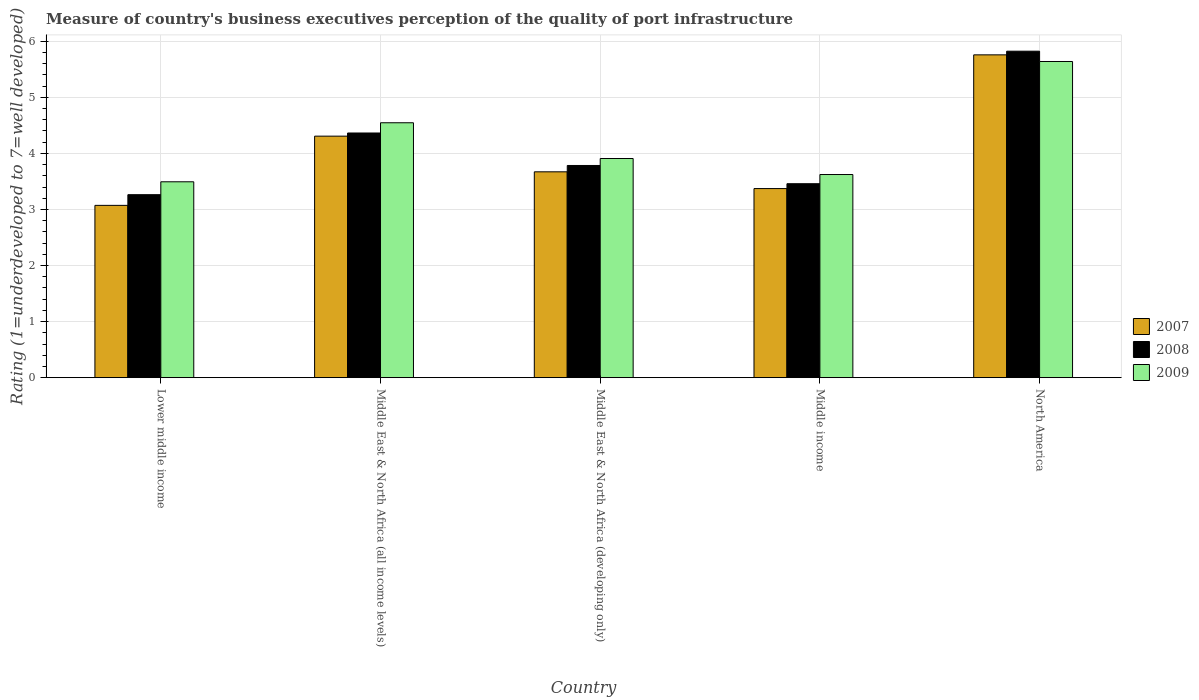How many different coloured bars are there?
Make the answer very short. 3. Are the number of bars per tick equal to the number of legend labels?
Ensure brevity in your answer.  Yes. Are the number of bars on each tick of the X-axis equal?
Make the answer very short. Yes. How many bars are there on the 5th tick from the left?
Provide a short and direct response. 3. How many bars are there on the 2nd tick from the right?
Provide a short and direct response. 3. What is the label of the 5th group of bars from the left?
Your response must be concise. North America. What is the ratings of the quality of port infrastructure in 2008 in Lower middle income?
Ensure brevity in your answer.  3.26. Across all countries, what is the maximum ratings of the quality of port infrastructure in 2008?
Provide a short and direct response. 5.82. Across all countries, what is the minimum ratings of the quality of port infrastructure in 2009?
Keep it short and to the point. 3.49. In which country was the ratings of the quality of port infrastructure in 2007 maximum?
Give a very brief answer. North America. In which country was the ratings of the quality of port infrastructure in 2008 minimum?
Keep it short and to the point. Lower middle income. What is the total ratings of the quality of port infrastructure in 2008 in the graph?
Make the answer very short. 20.7. What is the difference between the ratings of the quality of port infrastructure in 2007 in Middle East & North Africa (all income levels) and that in Middle income?
Ensure brevity in your answer.  0.94. What is the difference between the ratings of the quality of port infrastructure in 2007 in North America and the ratings of the quality of port infrastructure in 2008 in Middle income?
Your answer should be compact. 2.3. What is the average ratings of the quality of port infrastructure in 2009 per country?
Make the answer very short. 4.24. What is the difference between the ratings of the quality of port infrastructure of/in 2008 and ratings of the quality of port infrastructure of/in 2007 in Middle income?
Give a very brief answer. 0.09. In how many countries, is the ratings of the quality of port infrastructure in 2009 greater than 2.6?
Give a very brief answer. 5. What is the ratio of the ratings of the quality of port infrastructure in 2009 in Middle East & North Africa (all income levels) to that in North America?
Give a very brief answer. 0.81. What is the difference between the highest and the second highest ratings of the quality of port infrastructure in 2008?
Offer a very short reply. -0.58. What is the difference between the highest and the lowest ratings of the quality of port infrastructure in 2007?
Provide a short and direct response. 2.68. In how many countries, is the ratings of the quality of port infrastructure in 2007 greater than the average ratings of the quality of port infrastructure in 2007 taken over all countries?
Make the answer very short. 2. What does the 3rd bar from the left in Lower middle income represents?
Offer a very short reply. 2009. What does the 2nd bar from the right in Middle East & North Africa (developing only) represents?
Make the answer very short. 2008. Is it the case that in every country, the sum of the ratings of the quality of port infrastructure in 2007 and ratings of the quality of port infrastructure in 2008 is greater than the ratings of the quality of port infrastructure in 2009?
Your answer should be compact. Yes. How many countries are there in the graph?
Give a very brief answer. 5. What is the difference between two consecutive major ticks on the Y-axis?
Give a very brief answer. 1. Does the graph contain grids?
Provide a succinct answer. Yes. Where does the legend appear in the graph?
Your response must be concise. Center right. How are the legend labels stacked?
Provide a short and direct response. Vertical. What is the title of the graph?
Your answer should be compact. Measure of country's business executives perception of the quality of port infrastructure. Does "1970" appear as one of the legend labels in the graph?
Give a very brief answer. No. What is the label or title of the X-axis?
Provide a succinct answer. Country. What is the label or title of the Y-axis?
Offer a terse response. Rating (1=underdeveloped to 7=well developed). What is the Rating (1=underdeveloped to 7=well developed) of 2007 in Lower middle income?
Provide a short and direct response. 3.07. What is the Rating (1=underdeveloped to 7=well developed) in 2008 in Lower middle income?
Provide a succinct answer. 3.26. What is the Rating (1=underdeveloped to 7=well developed) in 2009 in Lower middle income?
Give a very brief answer. 3.49. What is the Rating (1=underdeveloped to 7=well developed) of 2007 in Middle East & North Africa (all income levels)?
Your answer should be compact. 4.31. What is the Rating (1=underdeveloped to 7=well developed) in 2008 in Middle East & North Africa (all income levels)?
Your answer should be very brief. 4.36. What is the Rating (1=underdeveloped to 7=well developed) in 2009 in Middle East & North Africa (all income levels)?
Keep it short and to the point. 4.55. What is the Rating (1=underdeveloped to 7=well developed) in 2007 in Middle East & North Africa (developing only)?
Offer a very short reply. 3.67. What is the Rating (1=underdeveloped to 7=well developed) in 2008 in Middle East & North Africa (developing only)?
Provide a succinct answer. 3.78. What is the Rating (1=underdeveloped to 7=well developed) in 2009 in Middle East & North Africa (developing only)?
Provide a succinct answer. 3.91. What is the Rating (1=underdeveloped to 7=well developed) of 2007 in Middle income?
Provide a short and direct response. 3.37. What is the Rating (1=underdeveloped to 7=well developed) of 2008 in Middle income?
Provide a short and direct response. 3.46. What is the Rating (1=underdeveloped to 7=well developed) of 2009 in Middle income?
Keep it short and to the point. 3.62. What is the Rating (1=underdeveloped to 7=well developed) in 2007 in North America?
Give a very brief answer. 5.76. What is the Rating (1=underdeveloped to 7=well developed) in 2008 in North America?
Ensure brevity in your answer.  5.82. What is the Rating (1=underdeveloped to 7=well developed) of 2009 in North America?
Your answer should be compact. 5.64. Across all countries, what is the maximum Rating (1=underdeveloped to 7=well developed) in 2007?
Your response must be concise. 5.76. Across all countries, what is the maximum Rating (1=underdeveloped to 7=well developed) of 2008?
Your response must be concise. 5.82. Across all countries, what is the maximum Rating (1=underdeveloped to 7=well developed) in 2009?
Offer a terse response. 5.64. Across all countries, what is the minimum Rating (1=underdeveloped to 7=well developed) of 2007?
Ensure brevity in your answer.  3.07. Across all countries, what is the minimum Rating (1=underdeveloped to 7=well developed) in 2008?
Offer a terse response. 3.26. Across all countries, what is the minimum Rating (1=underdeveloped to 7=well developed) of 2009?
Ensure brevity in your answer.  3.49. What is the total Rating (1=underdeveloped to 7=well developed) in 2007 in the graph?
Your response must be concise. 20.18. What is the total Rating (1=underdeveloped to 7=well developed) of 2008 in the graph?
Offer a very short reply. 20.7. What is the total Rating (1=underdeveloped to 7=well developed) of 2009 in the graph?
Your answer should be very brief. 21.21. What is the difference between the Rating (1=underdeveloped to 7=well developed) in 2007 in Lower middle income and that in Middle East & North Africa (all income levels)?
Give a very brief answer. -1.23. What is the difference between the Rating (1=underdeveloped to 7=well developed) of 2008 in Lower middle income and that in Middle East & North Africa (all income levels)?
Your response must be concise. -1.1. What is the difference between the Rating (1=underdeveloped to 7=well developed) of 2009 in Lower middle income and that in Middle East & North Africa (all income levels)?
Offer a very short reply. -1.05. What is the difference between the Rating (1=underdeveloped to 7=well developed) of 2007 in Lower middle income and that in Middle East & North Africa (developing only)?
Make the answer very short. -0.6. What is the difference between the Rating (1=underdeveloped to 7=well developed) of 2008 in Lower middle income and that in Middle East & North Africa (developing only)?
Give a very brief answer. -0.52. What is the difference between the Rating (1=underdeveloped to 7=well developed) of 2009 in Lower middle income and that in Middle East & North Africa (developing only)?
Keep it short and to the point. -0.42. What is the difference between the Rating (1=underdeveloped to 7=well developed) of 2007 in Lower middle income and that in Middle income?
Your answer should be very brief. -0.3. What is the difference between the Rating (1=underdeveloped to 7=well developed) in 2008 in Lower middle income and that in Middle income?
Offer a terse response. -0.2. What is the difference between the Rating (1=underdeveloped to 7=well developed) in 2009 in Lower middle income and that in Middle income?
Make the answer very short. -0.13. What is the difference between the Rating (1=underdeveloped to 7=well developed) of 2007 in Lower middle income and that in North America?
Make the answer very short. -2.68. What is the difference between the Rating (1=underdeveloped to 7=well developed) in 2008 in Lower middle income and that in North America?
Offer a terse response. -2.56. What is the difference between the Rating (1=underdeveloped to 7=well developed) of 2009 in Lower middle income and that in North America?
Ensure brevity in your answer.  -2.15. What is the difference between the Rating (1=underdeveloped to 7=well developed) of 2007 in Middle East & North Africa (all income levels) and that in Middle East & North Africa (developing only)?
Provide a succinct answer. 0.64. What is the difference between the Rating (1=underdeveloped to 7=well developed) in 2008 in Middle East & North Africa (all income levels) and that in Middle East & North Africa (developing only)?
Your answer should be very brief. 0.58. What is the difference between the Rating (1=underdeveloped to 7=well developed) in 2009 in Middle East & North Africa (all income levels) and that in Middle East & North Africa (developing only)?
Your response must be concise. 0.64. What is the difference between the Rating (1=underdeveloped to 7=well developed) in 2007 in Middle East & North Africa (all income levels) and that in Middle income?
Offer a terse response. 0.94. What is the difference between the Rating (1=underdeveloped to 7=well developed) in 2008 in Middle East & North Africa (all income levels) and that in Middle income?
Provide a short and direct response. 0.9. What is the difference between the Rating (1=underdeveloped to 7=well developed) of 2009 in Middle East & North Africa (all income levels) and that in Middle income?
Provide a succinct answer. 0.92. What is the difference between the Rating (1=underdeveloped to 7=well developed) of 2007 in Middle East & North Africa (all income levels) and that in North America?
Your answer should be very brief. -1.45. What is the difference between the Rating (1=underdeveloped to 7=well developed) of 2008 in Middle East & North Africa (all income levels) and that in North America?
Your response must be concise. -1.46. What is the difference between the Rating (1=underdeveloped to 7=well developed) in 2009 in Middle East & North Africa (all income levels) and that in North America?
Make the answer very short. -1.09. What is the difference between the Rating (1=underdeveloped to 7=well developed) in 2007 in Middle East & North Africa (developing only) and that in Middle income?
Your answer should be compact. 0.3. What is the difference between the Rating (1=underdeveloped to 7=well developed) of 2008 in Middle East & North Africa (developing only) and that in Middle income?
Keep it short and to the point. 0.33. What is the difference between the Rating (1=underdeveloped to 7=well developed) of 2009 in Middle East & North Africa (developing only) and that in Middle income?
Offer a terse response. 0.29. What is the difference between the Rating (1=underdeveloped to 7=well developed) in 2007 in Middle East & North Africa (developing only) and that in North America?
Your response must be concise. -2.09. What is the difference between the Rating (1=underdeveloped to 7=well developed) of 2008 in Middle East & North Africa (developing only) and that in North America?
Give a very brief answer. -2.04. What is the difference between the Rating (1=underdeveloped to 7=well developed) of 2009 in Middle East & North Africa (developing only) and that in North America?
Your answer should be compact. -1.73. What is the difference between the Rating (1=underdeveloped to 7=well developed) in 2007 in Middle income and that in North America?
Your answer should be very brief. -2.39. What is the difference between the Rating (1=underdeveloped to 7=well developed) in 2008 in Middle income and that in North America?
Offer a terse response. -2.36. What is the difference between the Rating (1=underdeveloped to 7=well developed) in 2009 in Middle income and that in North America?
Provide a succinct answer. -2.02. What is the difference between the Rating (1=underdeveloped to 7=well developed) of 2007 in Lower middle income and the Rating (1=underdeveloped to 7=well developed) of 2008 in Middle East & North Africa (all income levels)?
Provide a short and direct response. -1.29. What is the difference between the Rating (1=underdeveloped to 7=well developed) of 2007 in Lower middle income and the Rating (1=underdeveloped to 7=well developed) of 2009 in Middle East & North Africa (all income levels)?
Your answer should be compact. -1.47. What is the difference between the Rating (1=underdeveloped to 7=well developed) of 2008 in Lower middle income and the Rating (1=underdeveloped to 7=well developed) of 2009 in Middle East & North Africa (all income levels)?
Your answer should be very brief. -1.28. What is the difference between the Rating (1=underdeveloped to 7=well developed) in 2007 in Lower middle income and the Rating (1=underdeveloped to 7=well developed) in 2008 in Middle East & North Africa (developing only)?
Ensure brevity in your answer.  -0.71. What is the difference between the Rating (1=underdeveloped to 7=well developed) in 2007 in Lower middle income and the Rating (1=underdeveloped to 7=well developed) in 2009 in Middle East & North Africa (developing only)?
Your answer should be compact. -0.84. What is the difference between the Rating (1=underdeveloped to 7=well developed) of 2008 in Lower middle income and the Rating (1=underdeveloped to 7=well developed) of 2009 in Middle East & North Africa (developing only)?
Your response must be concise. -0.65. What is the difference between the Rating (1=underdeveloped to 7=well developed) of 2007 in Lower middle income and the Rating (1=underdeveloped to 7=well developed) of 2008 in Middle income?
Offer a very short reply. -0.39. What is the difference between the Rating (1=underdeveloped to 7=well developed) of 2007 in Lower middle income and the Rating (1=underdeveloped to 7=well developed) of 2009 in Middle income?
Provide a short and direct response. -0.55. What is the difference between the Rating (1=underdeveloped to 7=well developed) of 2008 in Lower middle income and the Rating (1=underdeveloped to 7=well developed) of 2009 in Middle income?
Give a very brief answer. -0.36. What is the difference between the Rating (1=underdeveloped to 7=well developed) in 2007 in Lower middle income and the Rating (1=underdeveloped to 7=well developed) in 2008 in North America?
Offer a very short reply. -2.75. What is the difference between the Rating (1=underdeveloped to 7=well developed) in 2007 in Lower middle income and the Rating (1=underdeveloped to 7=well developed) in 2009 in North America?
Your response must be concise. -2.57. What is the difference between the Rating (1=underdeveloped to 7=well developed) of 2008 in Lower middle income and the Rating (1=underdeveloped to 7=well developed) of 2009 in North America?
Offer a terse response. -2.38. What is the difference between the Rating (1=underdeveloped to 7=well developed) of 2007 in Middle East & North Africa (all income levels) and the Rating (1=underdeveloped to 7=well developed) of 2008 in Middle East & North Africa (developing only)?
Offer a very short reply. 0.52. What is the difference between the Rating (1=underdeveloped to 7=well developed) in 2007 in Middle East & North Africa (all income levels) and the Rating (1=underdeveloped to 7=well developed) in 2009 in Middle East & North Africa (developing only)?
Give a very brief answer. 0.4. What is the difference between the Rating (1=underdeveloped to 7=well developed) in 2008 in Middle East & North Africa (all income levels) and the Rating (1=underdeveloped to 7=well developed) in 2009 in Middle East & North Africa (developing only)?
Make the answer very short. 0.46. What is the difference between the Rating (1=underdeveloped to 7=well developed) of 2007 in Middle East & North Africa (all income levels) and the Rating (1=underdeveloped to 7=well developed) of 2008 in Middle income?
Your answer should be compact. 0.85. What is the difference between the Rating (1=underdeveloped to 7=well developed) of 2007 in Middle East & North Africa (all income levels) and the Rating (1=underdeveloped to 7=well developed) of 2009 in Middle income?
Provide a succinct answer. 0.68. What is the difference between the Rating (1=underdeveloped to 7=well developed) of 2008 in Middle East & North Africa (all income levels) and the Rating (1=underdeveloped to 7=well developed) of 2009 in Middle income?
Offer a very short reply. 0.74. What is the difference between the Rating (1=underdeveloped to 7=well developed) of 2007 in Middle East & North Africa (all income levels) and the Rating (1=underdeveloped to 7=well developed) of 2008 in North America?
Offer a very short reply. -1.52. What is the difference between the Rating (1=underdeveloped to 7=well developed) of 2007 in Middle East & North Africa (all income levels) and the Rating (1=underdeveloped to 7=well developed) of 2009 in North America?
Keep it short and to the point. -1.33. What is the difference between the Rating (1=underdeveloped to 7=well developed) in 2008 in Middle East & North Africa (all income levels) and the Rating (1=underdeveloped to 7=well developed) in 2009 in North America?
Provide a succinct answer. -1.28. What is the difference between the Rating (1=underdeveloped to 7=well developed) in 2007 in Middle East & North Africa (developing only) and the Rating (1=underdeveloped to 7=well developed) in 2008 in Middle income?
Make the answer very short. 0.21. What is the difference between the Rating (1=underdeveloped to 7=well developed) in 2007 in Middle East & North Africa (developing only) and the Rating (1=underdeveloped to 7=well developed) in 2009 in Middle income?
Give a very brief answer. 0.05. What is the difference between the Rating (1=underdeveloped to 7=well developed) in 2008 in Middle East & North Africa (developing only) and the Rating (1=underdeveloped to 7=well developed) in 2009 in Middle income?
Offer a very short reply. 0.16. What is the difference between the Rating (1=underdeveloped to 7=well developed) in 2007 in Middle East & North Africa (developing only) and the Rating (1=underdeveloped to 7=well developed) in 2008 in North America?
Your answer should be very brief. -2.15. What is the difference between the Rating (1=underdeveloped to 7=well developed) in 2007 in Middle East & North Africa (developing only) and the Rating (1=underdeveloped to 7=well developed) in 2009 in North America?
Ensure brevity in your answer.  -1.97. What is the difference between the Rating (1=underdeveloped to 7=well developed) in 2008 in Middle East & North Africa (developing only) and the Rating (1=underdeveloped to 7=well developed) in 2009 in North America?
Provide a short and direct response. -1.85. What is the difference between the Rating (1=underdeveloped to 7=well developed) of 2007 in Middle income and the Rating (1=underdeveloped to 7=well developed) of 2008 in North America?
Offer a very short reply. -2.45. What is the difference between the Rating (1=underdeveloped to 7=well developed) in 2007 in Middle income and the Rating (1=underdeveloped to 7=well developed) in 2009 in North America?
Ensure brevity in your answer.  -2.27. What is the difference between the Rating (1=underdeveloped to 7=well developed) of 2008 in Middle income and the Rating (1=underdeveloped to 7=well developed) of 2009 in North America?
Give a very brief answer. -2.18. What is the average Rating (1=underdeveloped to 7=well developed) of 2007 per country?
Offer a very short reply. 4.04. What is the average Rating (1=underdeveloped to 7=well developed) in 2008 per country?
Provide a succinct answer. 4.14. What is the average Rating (1=underdeveloped to 7=well developed) of 2009 per country?
Provide a short and direct response. 4.24. What is the difference between the Rating (1=underdeveloped to 7=well developed) in 2007 and Rating (1=underdeveloped to 7=well developed) in 2008 in Lower middle income?
Keep it short and to the point. -0.19. What is the difference between the Rating (1=underdeveloped to 7=well developed) of 2007 and Rating (1=underdeveloped to 7=well developed) of 2009 in Lower middle income?
Offer a terse response. -0.42. What is the difference between the Rating (1=underdeveloped to 7=well developed) of 2008 and Rating (1=underdeveloped to 7=well developed) of 2009 in Lower middle income?
Offer a very short reply. -0.23. What is the difference between the Rating (1=underdeveloped to 7=well developed) of 2007 and Rating (1=underdeveloped to 7=well developed) of 2008 in Middle East & North Africa (all income levels)?
Ensure brevity in your answer.  -0.06. What is the difference between the Rating (1=underdeveloped to 7=well developed) in 2007 and Rating (1=underdeveloped to 7=well developed) in 2009 in Middle East & North Africa (all income levels)?
Provide a succinct answer. -0.24. What is the difference between the Rating (1=underdeveloped to 7=well developed) in 2008 and Rating (1=underdeveloped to 7=well developed) in 2009 in Middle East & North Africa (all income levels)?
Offer a very short reply. -0.18. What is the difference between the Rating (1=underdeveloped to 7=well developed) of 2007 and Rating (1=underdeveloped to 7=well developed) of 2008 in Middle East & North Africa (developing only)?
Your answer should be very brief. -0.11. What is the difference between the Rating (1=underdeveloped to 7=well developed) of 2007 and Rating (1=underdeveloped to 7=well developed) of 2009 in Middle East & North Africa (developing only)?
Your response must be concise. -0.24. What is the difference between the Rating (1=underdeveloped to 7=well developed) in 2008 and Rating (1=underdeveloped to 7=well developed) in 2009 in Middle East & North Africa (developing only)?
Provide a succinct answer. -0.12. What is the difference between the Rating (1=underdeveloped to 7=well developed) in 2007 and Rating (1=underdeveloped to 7=well developed) in 2008 in Middle income?
Your response must be concise. -0.09. What is the difference between the Rating (1=underdeveloped to 7=well developed) in 2007 and Rating (1=underdeveloped to 7=well developed) in 2009 in Middle income?
Make the answer very short. -0.25. What is the difference between the Rating (1=underdeveloped to 7=well developed) of 2008 and Rating (1=underdeveloped to 7=well developed) of 2009 in Middle income?
Give a very brief answer. -0.16. What is the difference between the Rating (1=underdeveloped to 7=well developed) of 2007 and Rating (1=underdeveloped to 7=well developed) of 2008 in North America?
Provide a succinct answer. -0.07. What is the difference between the Rating (1=underdeveloped to 7=well developed) in 2007 and Rating (1=underdeveloped to 7=well developed) in 2009 in North America?
Keep it short and to the point. 0.12. What is the difference between the Rating (1=underdeveloped to 7=well developed) of 2008 and Rating (1=underdeveloped to 7=well developed) of 2009 in North America?
Your answer should be very brief. 0.18. What is the ratio of the Rating (1=underdeveloped to 7=well developed) in 2007 in Lower middle income to that in Middle East & North Africa (all income levels)?
Keep it short and to the point. 0.71. What is the ratio of the Rating (1=underdeveloped to 7=well developed) of 2008 in Lower middle income to that in Middle East & North Africa (all income levels)?
Your response must be concise. 0.75. What is the ratio of the Rating (1=underdeveloped to 7=well developed) of 2009 in Lower middle income to that in Middle East & North Africa (all income levels)?
Offer a very short reply. 0.77. What is the ratio of the Rating (1=underdeveloped to 7=well developed) of 2007 in Lower middle income to that in Middle East & North Africa (developing only)?
Provide a short and direct response. 0.84. What is the ratio of the Rating (1=underdeveloped to 7=well developed) in 2008 in Lower middle income to that in Middle East & North Africa (developing only)?
Your answer should be very brief. 0.86. What is the ratio of the Rating (1=underdeveloped to 7=well developed) in 2009 in Lower middle income to that in Middle East & North Africa (developing only)?
Your response must be concise. 0.89. What is the ratio of the Rating (1=underdeveloped to 7=well developed) in 2007 in Lower middle income to that in Middle income?
Your answer should be very brief. 0.91. What is the ratio of the Rating (1=underdeveloped to 7=well developed) of 2008 in Lower middle income to that in Middle income?
Make the answer very short. 0.94. What is the ratio of the Rating (1=underdeveloped to 7=well developed) of 2009 in Lower middle income to that in Middle income?
Provide a short and direct response. 0.96. What is the ratio of the Rating (1=underdeveloped to 7=well developed) in 2007 in Lower middle income to that in North America?
Ensure brevity in your answer.  0.53. What is the ratio of the Rating (1=underdeveloped to 7=well developed) of 2008 in Lower middle income to that in North America?
Keep it short and to the point. 0.56. What is the ratio of the Rating (1=underdeveloped to 7=well developed) of 2009 in Lower middle income to that in North America?
Your response must be concise. 0.62. What is the ratio of the Rating (1=underdeveloped to 7=well developed) of 2007 in Middle East & North Africa (all income levels) to that in Middle East & North Africa (developing only)?
Offer a terse response. 1.17. What is the ratio of the Rating (1=underdeveloped to 7=well developed) in 2008 in Middle East & North Africa (all income levels) to that in Middle East & North Africa (developing only)?
Offer a very short reply. 1.15. What is the ratio of the Rating (1=underdeveloped to 7=well developed) in 2009 in Middle East & North Africa (all income levels) to that in Middle East & North Africa (developing only)?
Your answer should be very brief. 1.16. What is the ratio of the Rating (1=underdeveloped to 7=well developed) of 2007 in Middle East & North Africa (all income levels) to that in Middle income?
Keep it short and to the point. 1.28. What is the ratio of the Rating (1=underdeveloped to 7=well developed) of 2008 in Middle East & North Africa (all income levels) to that in Middle income?
Give a very brief answer. 1.26. What is the ratio of the Rating (1=underdeveloped to 7=well developed) of 2009 in Middle East & North Africa (all income levels) to that in Middle income?
Your answer should be compact. 1.25. What is the ratio of the Rating (1=underdeveloped to 7=well developed) in 2007 in Middle East & North Africa (all income levels) to that in North America?
Offer a terse response. 0.75. What is the ratio of the Rating (1=underdeveloped to 7=well developed) of 2008 in Middle East & North Africa (all income levels) to that in North America?
Offer a terse response. 0.75. What is the ratio of the Rating (1=underdeveloped to 7=well developed) in 2009 in Middle East & North Africa (all income levels) to that in North America?
Your answer should be compact. 0.81. What is the ratio of the Rating (1=underdeveloped to 7=well developed) in 2007 in Middle East & North Africa (developing only) to that in Middle income?
Make the answer very short. 1.09. What is the ratio of the Rating (1=underdeveloped to 7=well developed) in 2008 in Middle East & North Africa (developing only) to that in Middle income?
Keep it short and to the point. 1.09. What is the ratio of the Rating (1=underdeveloped to 7=well developed) in 2009 in Middle East & North Africa (developing only) to that in Middle income?
Your answer should be very brief. 1.08. What is the ratio of the Rating (1=underdeveloped to 7=well developed) in 2007 in Middle East & North Africa (developing only) to that in North America?
Offer a very short reply. 0.64. What is the ratio of the Rating (1=underdeveloped to 7=well developed) in 2008 in Middle East & North Africa (developing only) to that in North America?
Ensure brevity in your answer.  0.65. What is the ratio of the Rating (1=underdeveloped to 7=well developed) in 2009 in Middle East & North Africa (developing only) to that in North America?
Make the answer very short. 0.69. What is the ratio of the Rating (1=underdeveloped to 7=well developed) of 2007 in Middle income to that in North America?
Give a very brief answer. 0.59. What is the ratio of the Rating (1=underdeveloped to 7=well developed) in 2008 in Middle income to that in North America?
Your response must be concise. 0.59. What is the ratio of the Rating (1=underdeveloped to 7=well developed) in 2009 in Middle income to that in North America?
Your response must be concise. 0.64. What is the difference between the highest and the second highest Rating (1=underdeveloped to 7=well developed) in 2007?
Provide a succinct answer. 1.45. What is the difference between the highest and the second highest Rating (1=underdeveloped to 7=well developed) in 2008?
Give a very brief answer. 1.46. What is the difference between the highest and the second highest Rating (1=underdeveloped to 7=well developed) of 2009?
Offer a terse response. 1.09. What is the difference between the highest and the lowest Rating (1=underdeveloped to 7=well developed) of 2007?
Your answer should be compact. 2.68. What is the difference between the highest and the lowest Rating (1=underdeveloped to 7=well developed) in 2008?
Offer a terse response. 2.56. What is the difference between the highest and the lowest Rating (1=underdeveloped to 7=well developed) of 2009?
Your response must be concise. 2.15. 